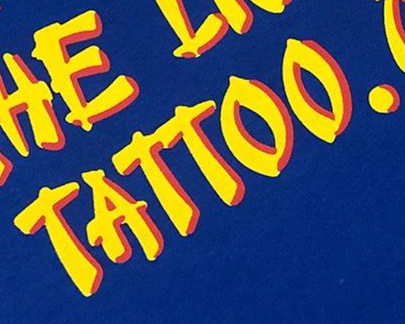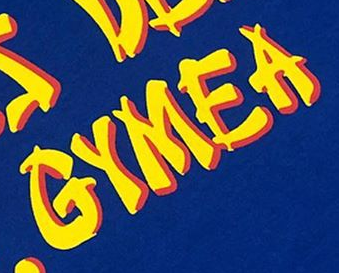Identify the words shown in these images in order, separated by a semicolon. TATTOO.; GYMEA 